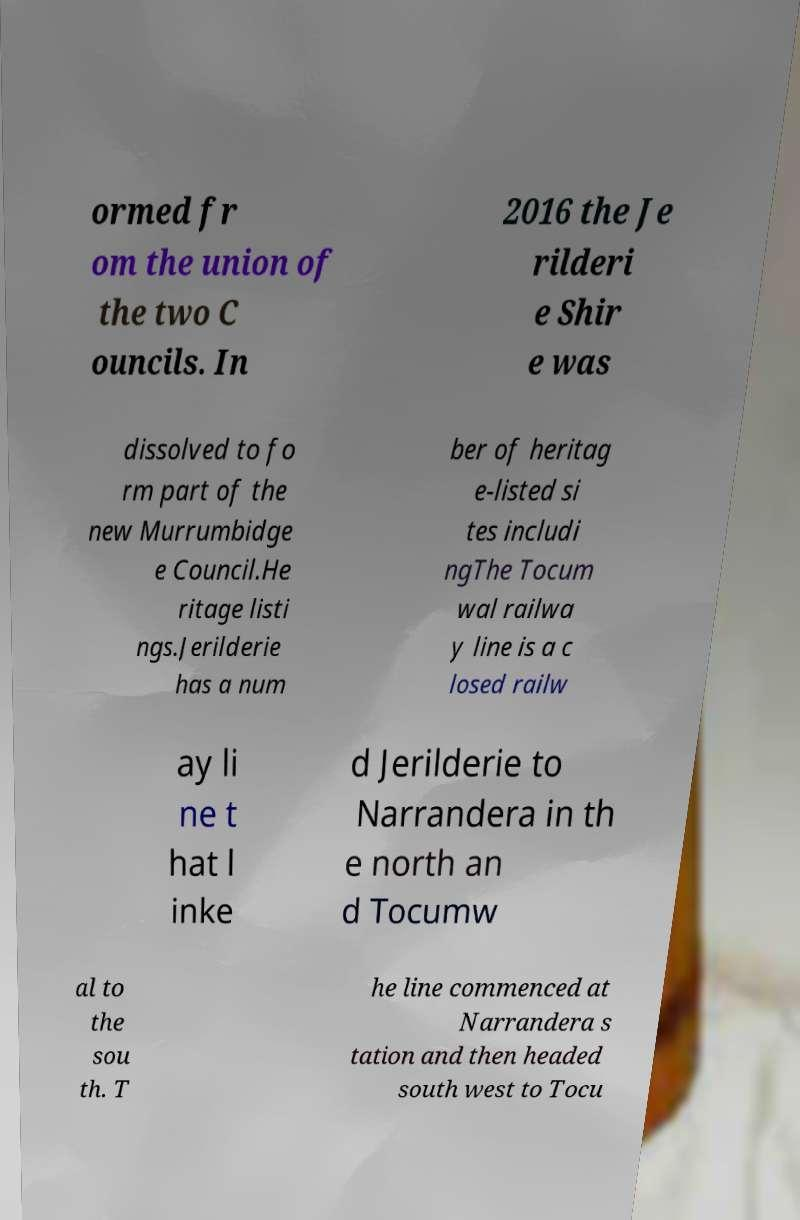Can you accurately transcribe the text from the provided image for me? ormed fr om the union of the two C ouncils. In 2016 the Je rilderi e Shir e was dissolved to fo rm part of the new Murrumbidge e Council.He ritage listi ngs.Jerilderie has a num ber of heritag e-listed si tes includi ngThe Tocum wal railwa y line is a c losed railw ay li ne t hat l inke d Jerilderie to Narrandera in th e north an d Tocumw al to the sou th. T he line commenced at Narrandera s tation and then headed south west to Tocu 